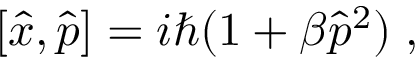Convert formula to latex. <formula><loc_0><loc_0><loc_500><loc_500>[ \hat { x } , \hat { p } ] = i \hbar { ( } 1 + \beta \hat { p } ^ { 2 } ) \, ,</formula> 